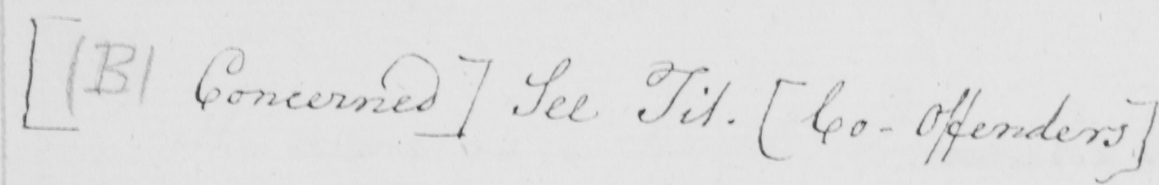Can you read and transcribe this handwriting? [  ( B )  Concerned ]  See Tit .  [ Co-Offenders ] 